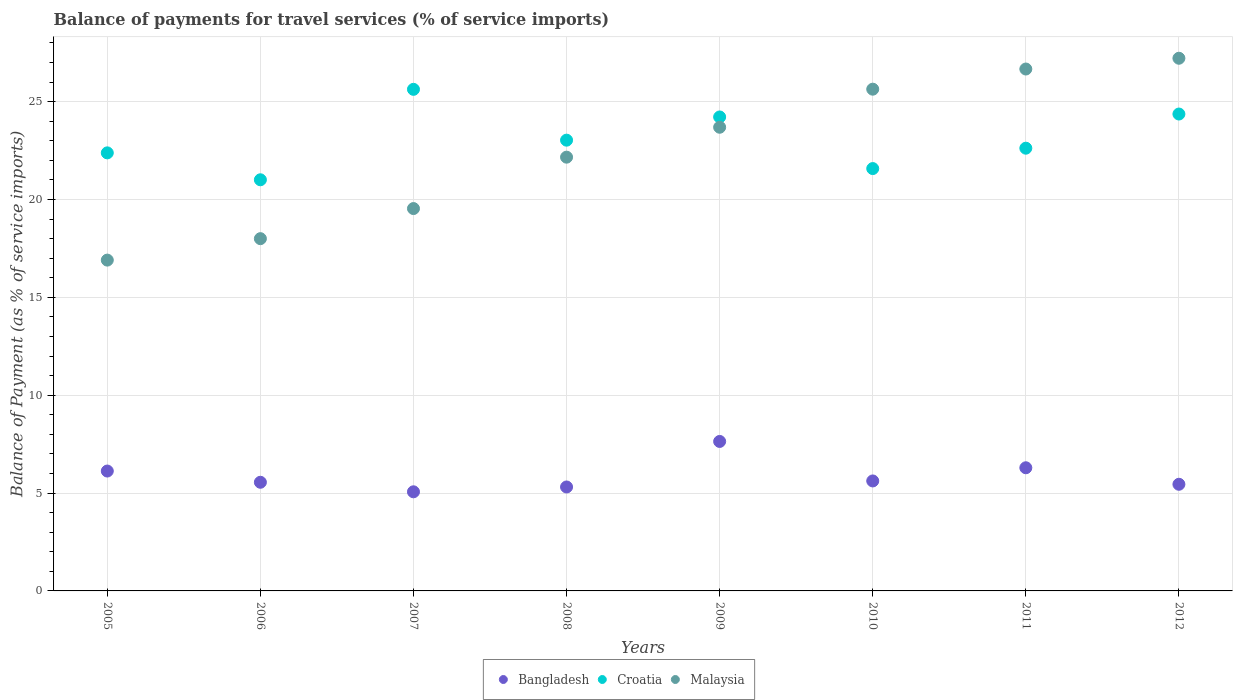What is the balance of payments for travel services in Bangladesh in 2012?
Give a very brief answer. 5.45. Across all years, what is the maximum balance of payments for travel services in Croatia?
Offer a very short reply. 25.63. Across all years, what is the minimum balance of payments for travel services in Croatia?
Ensure brevity in your answer.  21.01. In which year was the balance of payments for travel services in Croatia minimum?
Give a very brief answer. 2006. What is the total balance of payments for travel services in Croatia in the graph?
Make the answer very short. 184.84. What is the difference between the balance of payments for travel services in Croatia in 2006 and that in 2012?
Provide a short and direct response. -3.36. What is the difference between the balance of payments for travel services in Croatia in 2006 and the balance of payments for travel services in Bangladesh in 2012?
Keep it short and to the point. 15.56. What is the average balance of payments for travel services in Malaysia per year?
Provide a succinct answer. 22.48. In the year 2009, what is the difference between the balance of payments for travel services in Bangladesh and balance of payments for travel services in Malaysia?
Offer a terse response. -16.05. What is the ratio of the balance of payments for travel services in Malaysia in 2005 to that in 2012?
Offer a terse response. 0.62. Is the balance of payments for travel services in Croatia in 2005 less than that in 2007?
Keep it short and to the point. Yes. Is the difference between the balance of payments for travel services in Bangladesh in 2007 and 2012 greater than the difference between the balance of payments for travel services in Malaysia in 2007 and 2012?
Your response must be concise. Yes. What is the difference between the highest and the second highest balance of payments for travel services in Croatia?
Your response must be concise. 1.26. What is the difference between the highest and the lowest balance of payments for travel services in Croatia?
Keep it short and to the point. 4.62. Is it the case that in every year, the sum of the balance of payments for travel services in Croatia and balance of payments for travel services in Malaysia  is greater than the balance of payments for travel services in Bangladesh?
Provide a succinct answer. Yes. Does the balance of payments for travel services in Malaysia monotonically increase over the years?
Offer a terse response. Yes. Is the balance of payments for travel services in Croatia strictly less than the balance of payments for travel services in Malaysia over the years?
Offer a very short reply. No. Are the values on the major ticks of Y-axis written in scientific E-notation?
Offer a very short reply. No. Does the graph contain any zero values?
Your answer should be compact. No. Where does the legend appear in the graph?
Provide a short and direct response. Bottom center. How many legend labels are there?
Offer a very short reply. 3. What is the title of the graph?
Ensure brevity in your answer.  Balance of payments for travel services (% of service imports). What is the label or title of the X-axis?
Provide a succinct answer. Years. What is the label or title of the Y-axis?
Your answer should be compact. Balance of Payment (as % of service imports). What is the Balance of Payment (as % of service imports) of Bangladesh in 2005?
Your response must be concise. 6.13. What is the Balance of Payment (as % of service imports) in Croatia in 2005?
Offer a terse response. 22.38. What is the Balance of Payment (as % of service imports) of Malaysia in 2005?
Your response must be concise. 16.9. What is the Balance of Payment (as % of service imports) of Bangladesh in 2006?
Your response must be concise. 5.55. What is the Balance of Payment (as % of service imports) in Croatia in 2006?
Ensure brevity in your answer.  21.01. What is the Balance of Payment (as % of service imports) of Malaysia in 2006?
Your response must be concise. 18. What is the Balance of Payment (as % of service imports) in Bangladesh in 2007?
Offer a very short reply. 5.06. What is the Balance of Payment (as % of service imports) in Croatia in 2007?
Provide a short and direct response. 25.63. What is the Balance of Payment (as % of service imports) in Malaysia in 2007?
Give a very brief answer. 19.54. What is the Balance of Payment (as % of service imports) in Bangladesh in 2008?
Keep it short and to the point. 5.31. What is the Balance of Payment (as % of service imports) in Croatia in 2008?
Offer a terse response. 23.03. What is the Balance of Payment (as % of service imports) of Malaysia in 2008?
Ensure brevity in your answer.  22.16. What is the Balance of Payment (as % of service imports) of Bangladesh in 2009?
Give a very brief answer. 7.64. What is the Balance of Payment (as % of service imports) in Croatia in 2009?
Provide a short and direct response. 24.22. What is the Balance of Payment (as % of service imports) of Malaysia in 2009?
Provide a short and direct response. 23.69. What is the Balance of Payment (as % of service imports) in Bangladesh in 2010?
Offer a terse response. 5.62. What is the Balance of Payment (as % of service imports) in Croatia in 2010?
Make the answer very short. 21.58. What is the Balance of Payment (as % of service imports) of Malaysia in 2010?
Your answer should be very brief. 25.64. What is the Balance of Payment (as % of service imports) of Bangladesh in 2011?
Your answer should be compact. 6.29. What is the Balance of Payment (as % of service imports) in Croatia in 2011?
Provide a short and direct response. 22.62. What is the Balance of Payment (as % of service imports) in Malaysia in 2011?
Offer a terse response. 26.67. What is the Balance of Payment (as % of service imports) in Bangladesh in 2012?
Offer a very short reply. 5.45. What is the Balance of Payment (as % of service imports) of Croatia in 2012?
Ensure brevity in your answer.  24.37. What is the Balance of Payment (as % of service imports) of Malaysia in 2012?
Offer a terse response. 27.22. Across all years, what is the maximum Balance of Payment (as % of service imports) of Bangladesh?
Give a very brief answer. 7.64. Across all years, what is the maximum Balance of Payment (as % of service imports) in Croatia?
Ensure brevity in your answer.  25.63. Across all years, what is the maximum Balance of Payment (as % of service imports) in Malaysia?
Provide a succinct answer. 27.22. Across all years, what is the minimum Balance of Payment (as % of service imports) in Bangladesh?
Your response must be concise. 5.06. Across all years, what is the minimum Balance of Payment (as % of service imports) of Croatia?
Offer a very short reply. 21.01. Across all years, what is the minimum Balance of Payment (as % of service imports) in Malaysia?
Your answer should be compact. 16.9. What is the total Balance of Payment (as % of service imports) in Bangladesh in the graph?
Give a very brief answer. 47.05. What is the total Balance of Payment (as % of service imports) of Croatia in the graph?
Give a very brief answer. 184.84. What is the total Balance of Payment (as % of service imports) of Malaysia in the graph?
Offer a very short reply. 179.81. What is the difference between the Balance of Payment (as % of service imports) of Bangladesh in 2005 and that in 2006?
Give a very brief answer. 0.57. What is the difference between the Balance of Payment (as % of service imports) in Croatia in 2005 and that in 2006?
Provide a short and direct response. 1.38. What is the difference between the Balance of Payment (as % of service imports) of Malaysia in 2005 and that in 2006?
Ensure brevity in your answer.  -1.1. What is the difference between the Balance of Payment (as % of service imports) of Bangladesh in 2005 and that in 2007?
Your answer should be very brief. 1.06. What is the difference between the Balance of Payment (as % of service imports) in Croatia in 2005 and that in 2007?
Your answer should be very brief. -3.25. What is the difference between the Balance of Payment (as % of service imports) of Malaysia in 2005 and that in 2007?
Provide a short and direct response. -2.63. What is the difference between the Balance of Payment (as % of service imports) in Bangladesh in 2005 and that in 2008?
Your answer should be compact. 0.81. What is the difference between the Balance of Payment (as % of service imports) in Croatia in 2005 and that in 2008?
Provide a short and direct response. -0.65. What is the difference between the Balance of Payment (as % of service imports) of Malaysia in 2005 and that in 2008?
Your answer should be very brief. -5.26. What is the difference between the Balance of Payment (as % of service imports) of Bangladesh in 2005 and that in 2009?
Give a very brief answer. -1.51. What is the difference between the Balance of Payment (as % of service imports) of Croatia in 2005 and that in 2009?
Offer a very short reply. -1.83. What is the difference between the Balance of Payment (as % of service imports) in Malaysia in 2005 and that in 2009?
Make the answer very short. -6.79. What is the difference between the Balance of Payment (as % of service imports) of Bangladesh in 2005 and that in 2010?
Make the answer very short. 0.51. What is the difference between the Balance of Payment (as % of service imports) of Croatia in 2005 and that in 2010?
Your response must be concise. 0.8. What is the difference between the Balance of Payment (as % of service imports) in Malaysia in 2005 and that in 2010?
Your answer should be very brief. -8.73. What is the difference between the Balance of Payment (as % of service imports) of Bangladesh in 2005 and that in 2011?
Ensure brevity in your answer.  -0.17. What is the difference between the Balance of Payment (as % of service imports) in Croatia in 2005 and that in 2011?
Your response must be concise. -0.24. What is the difference between the Balance of Payment (as % of service imports) in Malaysia in 2005 and that in 2011?
Provide a succinct answer. -9.76. What is the difference between the Balance of Payment (as % of service imports) of Bangladesh in 2005 and that in 2012?
Keep it short and to the point. 0.68. What is the difference between the Balance of Payment (as % of service imports) of Croatia in 2005 and that in 2012?
Your response must be concise. -1.98. What is the difference between the Balance of Payment (as % of service imports) in Malaysia in 2005 and that in 2012?
Offer a terse response. -10.31. What is the difference between the Balance of Payment (as % of service imports) in Bangladesh in 2006 and that in 2007?
Your answer should be compact. 0.49. What is the difference between the Balance of Payment (as % of service imports) in Croatia in 2006 and that in 2007?
Give a very brief answer. -4.62. What is the difference between the Balance of Payment (as % of service imports) of Malaysia in 2006 and that in 2007?
Ensure brevity in your answer.  -1.54. What is the difference between the Balance of Payment (as % of service imports) of Bangladesh in 2006 and that in 2008?
Your answer should be very brief. 0.24. What is the difference between the Balance of Payment (as % of service imports) of Croatia in 2006 and that in 2008?
Your answer should be very brief. -2.02. What is the difference between the Balance of Payment (as % of service imports) in Malaysia in 2006 and that in 2008?
Make the answer very short. -4.16. What is the difference between the Balance of Payment (as % of service imports) of Bangladesh in 2006 and that in 2009?
Provide a succinct answer. -2.09. What is the difference between the Balance of Payment (as % of service imports) of Croatia in 2006 and that in 2009?
Keep it short and to the point. -3.21. What is the difference between the Balance of Payment (as % of service imports) in Malaysia in 2006 and that in 2009?
Provide a succinct answer. -5.69. What is the difference between the Balance of Payment (as % of service imports) of Bangladesh in 2006 and that in 2010?
Provide a succinct answer. -0.07. What is the difference between the Balance of Payment (as % of service imports) of Croatia in 2006 and that in 2010?
Provide a short and direct response. -0.57. What is the difference between the Balance of Payment (as % of service imports) in Malaysia in 2006 and that in 2010?
Offer a terse response. -7.64. What is the difference between the Balance of Payment (as % of service imports) in Bangladesh in 2006 and that in 2011?
Keep it short and to the point. -0.74. What is the difference between the Balance of Payment (as % of service imports) in Croatia in 2006 and that in 2011?
Provide a short and direct response. -1.61. What is the difference between the Balance of Payment (as % of service imports) of Malaysia in 2006 and that in 2011?
Your response must be concise. -8.67. What is the difference between the Balance of Payment (as % of service imports) of Bangladesh in 2006 and that in 2012?
Offer a very short reply. 0.1. What is the difference between the Balance of Payment (as % of service imports) in Croatia in 2006 and that in 2012?
Your answer should be very brief. -3.36. What is the difference between the Balance of Payment (as % of service imports) of Malaysia in 2006 and that in 2012?
Offer a terse response. -9.22. What is the difference between the Balance of Payment (as % of service imports) of Bangladesh in 2007 and that in 2008?
Make the answer very short. -0.25. What is the difference between the Balance of Payment (as % of service imports) in Croatia in 2007 and that in 2008?
Your response must be concise. 2.6. What is the difference between the Balance of Payment (as % of service imports) in Malaysia in 2007 and that in 2008?
Provide a short and direct response. -2.63. What is the difference between the Balance of Payment (as % of service imports) of Bangladesh in 2007 and that in 2009?
Keep it short and to the point. -2.57. What is the difference between the Balance of Payment (as % of service imports) in Croatia in 2007 and that in 2009?
Give a very brief answer. 1.41. What is the difference between the Balance of Payment (as % of service imports) in Malaysia in 2007 and that in 2009?
Your response must be concise. -4.15. What is the difference between the Balance of Payment (as % of service imports) in Bangladesh in 2007 and that in 2010?
Offer a very short reply. -0.55. What is the difference between the Balance of Payment (as % of service imports) in Croatia in 2007 and that in 2010?
Offer a terse response. 4.05. What is the difference between the Balance of Payment (as % of service imports) in Malaysia in 2007 and that in 2010?
Make the answer very short. -6.1. What is the difference between the Balance of Payment (as % of service imports) of Bangladesh in 2007 and that in 2011?
Ensure brevity in your answer.  -1.23. What is the difference between the Balance of Payment (as % of service imports) in Croatia in 2007 and that in 2011?
Provide a succinct answer. 3.01. What is the difference between the Balance of Payment (as % of service imports) of Malaysia in 2007 and that in 2011?
Give a very brief answer. -7.13. What is the difference between the Balance of Payment (as % of service imports) in Bangladesh in 2007 and that in 2012?
Your answer should be very brief. -0.38. What is the difference between the Balance of Payment (as % of service imports) of Croatia in 2007 and that in 2012?
Make the answer very short. 1.26. What is the difference between the Balance of Payment (as % of service imports) in Malaysia in 2007 and that in 2012?
Provide a succinct answer. -7.68. What is the difference between the Balance of Payment (as % of service imports) of Bangladesh in 2008 and that in 2009?
Make the answer very short. -2.33. What is the difference between the Balance of Payment (as % of service imports) of Croatia in 2008 and that in 2009?
Ensure brevity in your answer.  -1.19. What is the difference between the Balance of Payment (as % of service imports) in Malaysia in 2008 and that in 2009?
Your response must be concise. -1.53. What is the difference between the Balance of Payment (as % of service imports) in Bangladesh in 2008 and that in 2010?
Your answer should be very brief. -0.31. What is the difference between the Balance of Payment (as % of service imports) of Croatia in 2008 and that in 2010?
Your answer should be compact. 1.45. What is the difference between the Balance of Payment (as % of service imports) of Malaysia in 2008 and that in 2010?
Ensure brevity in your answer.  -3.47. What is the difference between the Balance of Payment (as % of service imports) of Bangladesh in 2008 and that in 2011?
Your response must be concise. -0.98. What is the difference between the Balance of Payment (as % of service imports) in Croatia in 2008 and that in 2011?
Make the answer very short. 0.41. What is the difference between the Balance of Payment (as % of service imports) of Malaysia in 2008 and that in 2011?
Ensure brevity in your answer.  -4.5. What is the difference between the Balance of Payment (as % of service imports) of Bangladesh in 2008 and that in 2012?
Provide a succinct answer. -0.14. What is the difference between the Balance of Payment (as % of service imports) in Croatia in 2008 and that in 2012?
Keep it short and to the point. -1.34. What is the difference between the Balance of Payment (as % of service imports) of Malaysia in 2008 and that in 2012?
Keep it short and to the point. -5.05. What is the difference between the Balance of Payment (as % of service imports) of Bangladesh in 2009 and that in 2010?
Provide a succinct answer. 2.02. What is the difference between the Balance of Payment (as % of service imports) in Croatia in 2009 and that in 2010?
Offer a very short reply. 2.64. What is the difference between the Balance of Payment (as % of service imports) of Malaysia in 2009 and that in 2010?
Offer a terse response. -1.95. What is the difference between the Balance of Payment (as % of service imports) in Bangladesh in 2009 and that in 2011?
Provide a short and direct response. 1.34. What is the difference between the Balance of Payment (as % of service imports) of Croatia in 2009 and that in 2011?
Keep it short and to the point. 1.6. What is the difference between the Balance of Payment (as % of service imports) of Malaysia in 2009 and that in 2011?
Provide a short and direct response. -2.98. What is the difference between the Balance of Payment (as % of service imports) of Bangladesh in 2009 and that in 2012?
Ensure brevity in your answer.  2.19. What is the difference between the Balance of Payment (as % of service imports) in Croatia in 2009 and that in 2012?
Your answer should be very brief. -0.15. What is the difference between the Balance of Payment (as % of service imports) in Malaysia in 2009 and that in 2012?
Give a very brief answer. -3.53. What is the difference between the Balance of Payment (as % of service imports) in Bangladesh in 2010 and that in 2011?
Your answer should be very brief. -0.67. What is the difference between the Balance of Payment (as % of service imports) in Croatia in 2010 and that in 2011?
Your response must be concise. -1.04. What is the difference between the Balance of Payment (as % of service imports) in Malaysia in 2010 and that in 2011?
Your answer should be very brief. -1.03. What is the difference between the Balance of Payment (as % of service imports) in Bangladesh in 2010 and that in 2012?
Give a very brief answer. 0.17. What is the difference between the Balance of Payment (as % of service imports) of Croatia in 2010 and that in 2012?
Offer a very short reply. -2.79. What is the difference between the Balance of Payment (as % of service imports) in Malaysia in 2010 and that in 2012?
Your answer should be very brief. -1.58. What is the difference between the Balance of Payment (as % of service imports) in Bangladesh in 2011 and that in 2012?
Your answer should be compact. 0.84. What is the difference between the Balance of Payment (as % of service imports) in Croatia in 2011 and that in 2012?
Provide a succinct answer. -1.75. What is the difference between the Balance of Payment (as % of service imports) of Malaysia in 2011 and that in 2012?
Offer a very short reply. -0.55. What is the difference between the Balance of Payment (as % of service imports) in Bangladesh in 2005 and the Balance of Payment (as % of service imports) in Croatia in 2006?
Give a very brief answer. -14.88. What is the difference between the Balance of Payment (as % of service imports) of Bangladesh in 2005 and the Balance of Payment (as % of service imports) of Malaysia in 2006?
Your answer should be very brief. -11.87. What is the difference between the Balance of Payment (as % of service imports) in Croatia in 2005 and the Balance of Payment (as % of service imports) in Malaysia in 2006?
Ensure brevity in your answer.  4.38. What is the difference between the Balance of Payment (as % of service imports) in Bangladesh in 2005 and the Balance of Payment (as % of service imports) in Croatia in 2007?
Provide a short and direct response. -19.5. What is the difference between the Balance of Payment (as % of service imports) in Bangladesh in 2005 and the Balance of Payment (as % of service imports) in Malaysia in 2007?
Provide a short and direct response. -13.41. What is the difference between the Balance of Payment (as % of service imports) in Croatia in 2005 and the Balance of Payment (as % of service imports) in Malaysia in 2007?
Ensure brevity in your answer.  2.85. What is the difference between the Balance of Payment (as % of service imports) in Bangladesh in 2005 and the Balance of Payment (as % of service imports) in Croatia in 2008?
Ensure brevity in your answer.  -16.91. What is the difference between the Balance of Payment (as % of service imports) of Bangladesh in 2005 and the Balance of Payment (as % of service imports) of Malaysia in 2008?
Ensure brevity in your answer.  -16.04. What is the difference between the Balance of Payment (as % of service imports) of Croatia in 2005 and the Balance of Payment (as % of service imports) of Malaysia in 2008?
Keep it short and to the point. 0.22. What is the difference between the Balance of Payment (as % of service imports) in Bangladesh in 2005 and the Balance of Payment (as % of service imports) in Croatia in 2009?
Provide a short and direct response. -18.09. What is the difference between the Balance of Payment (as % of service imports) in Bangladesh in 2005 and the Balance of Payment (as % of service imports) in Malaysia in 2009?
Your response must be concise. -17.57. What is the difference between the Balance of Payment (as % of service imports) in Croatia in 2005 and the Balance of Payment (as % of service imports) in Malaysia in 2009?
Keep it short and to the point. -1.31. What is the difference between the Balance of Payment (as % of service imports) of Bangladesh in 2005 and the Balance of Payment (as % of service imports) of Croatia in 2010?
Keep it short and to the point. -15.46. What is the difference between the Balance of Payment (as % of service imports) in Bangladesh in 2005 and the Balance of Payment (as % of service imports) in Malaysia in 2010?
Provide a succinct answer. -19.51. What is the difference between the Balance of Payment (as % of service imports) in Croatia in 2005 and the Balance of Payment (as % of service imports) in Malaysia in 2010?
Offer a terse response. -3.25. What is the difference between the Balance of Payment (as % of service imports) of Bangladesh in 2005 and the Balance of Payment (as % of service imports) of Croatia in 2011?
Provide a short and direct response. -16.5. What is the difference between the Balance of Payment (as % of service imports) in Bangladesh in 2005 and the Balance of Payment (as % of service imports) in Malaysia in 2011?
Your answer should be very brief. -20.54. What is the difference between the Balance of Payment (as % of service imports) in Croatia in 2005 and the Balance of Payment (as % of service imports) in Malaysia in 2011?
Ensure brevity in your answer.  -4.28. What is the difference between the Balance of Payment (as % of service imports) of Bangladesh in 2005 and the Balance of Payment (as % of service imports) of Croatia in 2012?
Offer a terse response. -18.24. What is the difference between the Balance of Payment (as % of service imports) of Bangladesh in 2005 and the Balance of Payment (as % of service imports) of Malaysia in 2012?
Keep it short and to the point. -21.09. What is the difference between the Balance of Payment (as % of service imports) in Croatia in 2005 and the Balance of Payment (as % of service imports) in Malaysia in 2012?
Your answer should be very brief. -4.83. What is the difference between the Balance of Payment (as % of service imports) of Bangladesh in 2006 and the Balance of Payment (as % of service imports) of Croatia in 2007?
Make the answer very short. -20.08. What is the difference between the Balance of Payment (as % of service imports) of Bangladesh in 2006 and the Balance of Payment (as % of service imports) of Malaysia in 2007?
Your answer should be very brief. -13.99. What is the difference between the Balance of Payment (as % of service imports) in Croatia in 2006 and the Balance of Payment (as % of service imports) in Malaysia in 2007?
Offer a terse response. 1.47. What is the difference between the Balance of Payment (as % of service imports) in Bangladesh in 2006 and the Balance of Payment (as % of service imports) in Croatia in 2008?
Your response must be concise. -17.48. What is the difference between the Balance of Payment (as % of service imports) of Bangladesh in 2006 and the Balance of Payment (as % of service imports) of Malaysia in 2008?
Give a very brief answer. -16.61. What is the difference between the Balance of Payment (as % of service imports) in Croatia in 2006 and the Balance of Payment (as % of service imports) in Malaysia in 2008?
Give a very brief answer. -1.16. What is the difference between the Balance of Payment (as % of service imports) of Bangladesh in 2006 and the Balance of Payment (as % of service imports) of Croatia in 2009?
Provide a succinct answer. -18.67. What is the difference between the Balance of Payment (as % of service imports) in Bangladesh in 2006 and the Balance of Payment (as % of service imports) in Malaysia in 2009?
Provide a short and direct response. -18.14. What is the difference between the Balance of Payment (as % of service imports) in Croatia in 2006 and the Balance of Payment (as % of service imports) in Malaysia in 2009?
Offer a terse response. -2.68. What is the difference between the Balance of Payment (as % of service imports) in Bangladesh in 2006 and the Balance of Payment (as % of service imports) in Croatia in 2010?
Offer a very short reply. -16.03. What is the difference between the Balance of Payment (as % of service imports) of Bangladesh in 2006 and the Balance of Payment (as % of service imports) of Malaysia in 2010?
Give a very brief answer. -20.08. What is the difference between the Balance of Payment (as % of service imports) of Croatia in 2006 and the Balance of Payment (as % of service imports) of Malaysia in 2010?
Your answer should be very brief. -4.63. What is the difference between the Balance of Payment (as % of service imports) of Bangladesh in 2006 and the Balance of Payment (as % of service imports) of Croatia in 2011?
Offer a very short reply. -17.07. What is the difference between the Balance of Payment (as % of service imports) in Bangladesh in 2006 and the Balance of Payment (as % of service imports) in Malaysia in 2011?
Your answer should be very brief. -21.12. What is the difference between the Balance of Payment (as % of service imports) in Croatia in 2006 and the Balance of Payment (as % of service imports) in Malaysia in 2011?
Provide a succinct answer. -5.66. What is the difference between the Balance of Payment (as % of service imports) of Bangladesh in 2006 and the Balance of Payment (as % of service imports) of Croatia in 2012?
Provide a succinct answer. -18.82. What is the difference between the Balance of Payment (as % of service imports) in Bangladesh in 2006 and the Balance of Payment (as % of service imports) in Malaysia in 2012?
Your answer should be very brief. -21.67. What is the difference between the Balance of Payment (as % of service imports) of Croatia in 2006 and the Balance of Payment (as % of service imports) of Malaysia in 2012?
Your answer should be compact. -6.21. What is the difference between the Balance of Payment (as % of service imports) of Bangladesh in 2007 and the Balance of Payment (as % of service imports) of Croatia in 2008?
Make the answer very short. -17.97. What is the difference between the Balance of Payment (as % of service imports) of Bangladesh in 2007 and the Balance of Payment (as % of service imports) of Malaysia in 2008?
Offer a terse response. -17.1. What is the difference between the Balance of Payment (as % of service imports) of Croatia in 2007 and the Balance of Payment (as % of service imports) of Malaysia in 2008?
Your answer should be compact. 3.47. What is the difference between the Balance of Payment (as % of service imports) in Bangladesh in 2007 and the Balance of Payment (as % of service imports) in Croatia in 2009?
Make the answer very short. -19.15. What is the difference between the Balance of Payment (as % of service imports) of Bangladesh in 2007 and the Balance of Payment (as % of service imports) of Malaysia in 2009?
Provide a short and direct response. -18.63. What is the difference between the Balance of Payment (as % of service imports) in Croatia in 2007 and the Balance of Payment (as % of service imports) in Malaysia in 2009?
Your answer should be very brief. 1.94. What is the difference between the Balance of Payment (as % of service imports) in Bangladesh in 2007 and the Balance of Payment (as % of service imports) in Croatia in 2010?
Offer a very short reply. -16.52. What is the difference between the Balance of Payment (as % of service imports) of Bangladesh in 2007 and the Balance of Payment (as % of service imports) of Malaysia in 2010?
Keep it short and to the point. -20.57. What is the difference between the Balance of Payment (as % of service imports) of Croatia in 2007 and the Balance of Payment (as % of service imports) of Malaysia in 2010?
Offer a terse response. -0.01. What is the difference between the Balance of Payment (as % of service imports) of Bangladesh in 2007 and the Balance of Payment (as % of service imports) of Croatia in 2011?
Provide a succinct answer. -17.56. What is the difference between the Balance of Payment (as % of service imports) of Bangladesh in 2007 and the Balance of Payment (as % of service imports) of Malaysia in 2011?
Give a very brief answer. -21.6. What is the difference between the Balance of Payment (as % of service imports) in Croatia in 2007 and the Balance of Payment (as % of service imports) in Malaysia in 2011?
Offer a very short reply. -1.04. What is the difference between the Balance of Payment (as % of service imports) in Bangladesh in 2007 and the Balance of Payment (as % of service imports) in Croatia in 2012?
Keep it short and to the point. -19.3. What is the difference between the Balance of Payment (as % of service imports) of Bangladesh in 2007 and the Balance of Payment (as % of service imports) of Malaysia in 2012?
Ensure brevity in your answer.  -22.15. What is the difference between the Balance of Payment (as % of service imports) of Croatia in 2007 and the Balance of Payment (as % of service imports) of Malaysia in 2012?
Keep it short and to the point. -1.59. What is the difference between the Balance of Payment (as % of service imports) in Bangladesh in 2008 and the Balance of Payment (as % of service imports) in Croatia in 2009?
Keep it short and to the point. -18.91. What is the difference between the Balance of Payment (as % of service imports) of Bangladesh in 2008 and the Balance of Payment (as % of service imports) of Malaysia in 2009?
Offer a very short reply. -18.38. What is the difference between the Balance of Payment (as % of service imports) of Croatia in 2008 and the Balance of Payment (as % of service imports) of Malaysia in 2009?
Offer a very short reply. -0.66. What is the difference between the Balance of Payment (as % of service imports) of Bangladesh in 2008 and the Balance of Payment (as % of service imports) of Croatia in 2010?
Provide a short and direct response. -16.27. What is the difference between the Balance of Payment (as % of service imports) of Bangladesh in 2008 and the Balance of Payment (as % of service imports) of Malaysia in 2010?
Offer a very short reply. -20.33. What is the difference between the Balance of Payment (as % of service imports) in Croatia in 2008 and the Balance of Payment (as % of service imports) in Malaysia in 2010?
Provide a short and direct response. -2.6. What is the difference between the Balance of Payment (as % of service imports) of Bangladesh in 2008 and the Balance of Payment (as % of service imports) of Croatia in 2011?
Provide a short and direct response. -17.31. What is the difference between the Balance of Payment (as % of service imports) in Bangladesh in 2008 and the Balance of Payment (as % of service imports) in Malaysia in 2011?
Provide a short and direct response. -21.36. What is the difference between the Balance of Payment (as % of service imports) of Croatia in 2008 and the Balance of Payment (as % of service imports) of Malaysia in 2011?
Offer a terse response. -3.64. What is the difference between the Balance of Payment (as % of service imports) in Bangladesh in 2008 and the Balance of Payment (as % of service imports) in Croatia in 2012?
Offer a terse response. -19.06. What is the difference between the Balance of Payment (as % of service imports) of Bangladesh in 2008 and the Balance of Payment (as % of service imports) of Malaysia in 2012?
Offer a very short reply. -21.91. What is the difference between the Balance of Payment (as % of service imports) in Croatia in 2008 and the Balance of Payment (as % of service imports) in Malaysia in 2012?
Ensure brevity in your answer.  -4.19. What is the difference between the Balance of Payment (as % of service imports) in Bangladesh in 2009 and the Balance of Payment (as % of service imports) in Croatia in 2010?
Ensure brevity in your answer.  -13.94. What is the difference between the Balance of Payment (as % of service imports) of Bangladesh in 2009 and the Balance of Payment (as % of service imports) of Malaysia in 2010?
Ensure brevity in your answer.  -18. What is the difference between the Balance of Payment (as % of service imports) in Croatia in 2009 and the Balance of Payment (as % of service imports) in Malaysia in 2010?
Provide a short and direct response. -1.42. What is the difference between the Balance of Payment (as % of service imports) of Bangladesh in 2009 and the Balance of Payment (as % of service imports) of Croatia in 2011?
Give a very brief answer. -14.98. What is the difference between the Balance of Payment (as % of service imports) of Bangladesh in 2009 and the Balance of Payment (as % of service imports) of Malaysia in 2011?
Your answer should be compact. -19.03. What is the difference between the Balance of Payment (as % of service imports) of Croatia in 2009 and the Balance of Payment (as % of service imports) of Malaysia in 2011?
Ensure brevity in your answer.  -2.45. What is the difference between the Balance of Payment (as % of service imports) in Bangladesh in 2009 and the Balance of Payment (as % of service imports) in Croatia in 2012?
Give a very brief answer. -16.73. What is the difference between the Balance of Payment (as % of service imports) in Bangladesh in 2009 and the Balance of Payment (as % of service imports) in Malaysia in 2012?
Ensure brevity in your answer.  -19.58. What is the difference between the Balance of Payment (as % of service imports) in Croatia in 2009 and the Balance of Payment (as % of service imports) in Malaysia in 2012?
Your response must be concise. -3. What is the difference between the Balance of Payment (as % of service imports) in Bangladesh in 2010 and the Balance of Payment (as % of service imports) in Croatia in 2011?
Keep it short and to the point. -17. What is the difference between the Balance of Payment (as % of service imports) of Bangladesh in 2010 and the Balance of Payment (as % of service imports) of Malaysia in 2011?
Provide a succinct answer. -21.05. What is the difference between the Balance of Payment (as % of service imports) of Croatia in 2010 and the Balance of Payment (as % of service imports) of Malaysia in 2011?
Provide a succinct answer. -5.09. What is the difference between the Balance of Payment (as % of service imports) of Bangladesh in 2010 and the Balance of Payment (as % of service imports) of Croatia in 2012?
Your answer should be compact. -18.75. What is the difference between the Balance of Payment (as % of service imports) of Bangladesh in 2010 and the Balance of Payment (as % of service imports) of Malaysia in 2012?
Offer a terse response. -21.6. What is the difference between the Balance of Payment (as % of service imports) in Croatia in 2010 and the Balance of Payment (as % of service imports) in Malaysia in 2012?
Provide a short and direct response. -5.64. What is the difference between the Balance of Payment (as % of service imports) of Bangladesh in 2011 and the Balance of Payment (as % of service imports) of Croatia in 2012?
Your answer should be very brief. -18.07. What is the difference between the Balance of Payment (as % of service imports) of Bangladesh in 2011 and the Balance of Payment (as % of service imports) of Malaysia in 2012?
Your response must be concise. -20.92. What is the difference between the Balance of Payment (as % of service imports) in Croatia in 2011 and the Balance of Payment (as % of service imports) in Malaysia in 2012?
Your response must be concise. -4.6. What is the average Balance of Payment (as % of service imports) of Bangladesh per year?
Offer a terse response. 5.88. What is the average Balance of Payment (as % of service imports) in Croatia per year?
Offer a very short reply. 23.1. What is the average Balance of Payment (as % of service imports) of Malaysia per year?
Offer a terse response. 22.48. In the year 2005, what is the difference between the Balance of Payment (as % of service imports) of Bangladesh and Balance of Payment (as % of service imports) of Croatia?
Keep it short and to the point. -16.26. In the year 2005, what is the difference between the Balance of Payment (as % of service imports) in Bangladesh and Balance of Payment (as % of service imports) in Malaysia?
Provide a succinct answer. -10.78. In the year 2005, what is the difference between the Balance of Payment (as % of service imports) of Croatia and Balance of Payment (as % of service imports) of Malaysia?
Give a very brief answer. 5.48. In the year 2006, what is the difference between the Balance of Payment (as % of service imports) of Bangladesh and Balance of Payment (as % of service imports) of Croatia?
Provide a succinct answer. -15.46. In the year 2006, what is the difference between the Balance of Payment (as % of service imports) of Bangladesh and Balance of Payment (as % of service imports) of Malaysia?
Make the answer very short. -12.45. In the year 2006, what is the difference between the Balance of Payment (as % of service imports) of Croatia and Balance of Payment (as % of service imports) of Malaysia?
Provide a short and direct response. 3.01. In the year 2007, what is the difference between the Balance of Payment (as % of service imports) in Bangladesh and Balance of Payment (as % of service imports) in Croatia?
Keep it short and to the point. -20.56. In the year 2007, what is the difference between the Balance of Payment (as % of service imports) of Bangladesh and Balance of Payment (as % of service imports) of Malaysia?
Give a very brief answer. -14.47. In the year 2007, what is the difference between the Balance of Payment (as % of service imports) of Croatia and Balance of Payment (as % of service imports) of Malaysia?
Your answer should be compact. 6.09. In the year 2008, what is the difference between the Balance of Payment (as % of service imports) in Bangladesh and Balance of Payment (as % of service imports) in Croatia?
Offer a terse response. -17.72. In the year 2008, what is the difference between the Balance of Payment (as % of service imports) of Bangladesh and Balance of Payment (as % of service imports) of Malaysia?
Your response must be concise. -16.85. In the year 2008, what is the difference between the Balance of Payment (as % of service imports) of Croatia and Balance of Payment (as % of service imports) of Malaysia?
Your answer should be very brief. 0.87. In the year 2009, what is the difference between the Balance of Payment (as % of service imports) of Bangladesh and Balance of Payment (as % of service imports) of Croatia?
Your answer should be very brief. -16.58. In the year 2009, what is the difference between the Balance of Payment (as % of service imports) in Bangladesh and Balance of Payment (as % of service imports) in Malaysia?
Keep it short and to the point. -16.05. In the year 2009, what is the difference between the Balance of Payment (as % of service imports) of Croatia and Balance of Payment (as % of service imports) of Malaysia?
Your answer should be very brief. 0.53. In the year 2010, what is the difference between the Balance of Payment (as % of service imports) of Bangladesh and Balance of Payment (as % of service imports) of Croatia?
Provide a short and direct response. -15.96. In the year 2010, what is the difference between the Balance of Payment (as % of service imports) of Bangladesh and Balance of Payment (as % of service imports) of Malaysia?
Give a very brief answer. -20.02. In the year 2010, what is the difference between the Balance of Payment (as % of service imports) of Croatia and Balance of Payment (as % of service imports) of Malaysia?
Your answer should be compact. -4.06. In the year 2011, what is the difference between the Balance of Payment (as % of service imports) of Bangladesh and Balance of Payment (as % of service imports) of Croatia?
Give a very brief answer. -16.33. In the year 2011, what is the difference between the Balance of Payment (as % of service imports) of Bangladesh and Balance of Payment (as % of service imports) of Malaysia?
Keep it short and to the point. -20.37. In the year 2011, what is the difference between the Balance of Payment (as % of service imports) in Croatia and Balance of Payment (as % of service imports) in Malaysia?
Make the answer very short. -4.05. In the year 2012, what is the difference between the Balance of Payment (as % of service imports) of Bangladesh and Balance of Payment (as % of service imports) of Croatia?
Your answer should be compact. -18.92. In the year 2012, what is the difference between the Balance of Payment (as % of service imports) in Bangladesh and Balance of Payment (as % of service imports) in Malaysia?
Give a very brief answer. -21.77. In the year 2012, what is the difference between the Balance of Payment (as % of service imports) in Croatia and Balance of Payment (as % of service imports) in Malaysia?
Your response must be concise. -2.85. What is the ratio of the Balance of Payment (as % of service imports) of Bangladesh in 2005 to that in 2006?
Provide a short and direct response. 1.1. What is the ratio of the Balance of Payment (as % of service imports) of Croatia in 2005 to that in 2006?
Provide a short and direct response. 1.07. What is the ratio of the Balance of Payment (as % of service imports) in Malaysia in 2005 to that in 2006?
Keep it short and to the point. 0.94. What is the ratio of the Balance of Payment (as % of service imports) in Bangladesh in 2005 to that in 2007?
Your answer should be compact. 1.21. What is the ratio of the Balance of Payment (as % of service imports) in Croatia in 2005 to that in 2007?
Ensure brevity in your answer.  0.87. What is the ratio of the Balance of Payment (as % of service imports) in Malaysia in 2005 to that in 2007?
Offer a very short reply. 0.87. What is the ratio of the Balance of Payment (as % of service imports) of Bangladesh in 2005 to that in 2008?
Provide a succinct answer. 1.15. What is the ratio of the Balance of Payment (as % of service imports) in Croatia in 2005 to that in 2008?
Keep it short and to the point. 0.97. What is the ratio of the Balance of Payment (as % of service imports) of Malaysia in 2005 to that in 2008?
Make the answer very short. 0.76. What is the ratio of the Balance of Payment (as % of service imports) of Bangladesh in 2005 to that in 2009?
Keep it short and to the point. 0.8. What is the ratio of the Balance of Payment (as % of service imports) in Croatia in 2005 to that in 2009?
Make the answer very short. 0.92. What is the ratio of the Balance of Payment (as % of service imports) of Malaysia in 2005 to that in 2009?
Offer a very short reply. 0.71. What is the ratio of the Balance of Payment (as % of service imports) in Bangladesh in 2005 to that in 2010?
Offer a very short reply. 1.09. What is the ratio of the Balance of Payment (as % of service imports) of Croatia in 2005 to that in 2010?
Ensure brevity in your answer.  1.04. What is the ratio of the Balance of Payment (as % of service imports) of Malaysia in 2005 to that in 2010?
Ensure brevity in your answer.  0.66. What is the ratio of the Balance of Payment (as % of service imports) in Bangladesh in 2005 to that in 2011?
Keep it short and to the point. 0.97. What is the ratio of the Balance of Payment (as % of service imports) in Croatia in 2005 to that in 2011?
Keep it short and to the point. 0.99. What is the ratio of the Balance of Payment (as % of service imports) in Malaysia in 2005 to that in 2011?
Ensure brevity in your answer.  0.63. What is the ratio of the Balance of Payment (as % of service imports) of Bangladesh in 2005 to that in 2012?
Offer a very short reply. 1.12. What is the ratio of the Balance of Payment (as % of service imports) of Croatia in 2005 to that in 2012?
Give a very brief answer. 0.92. What is the ratio of the Balance of Payment (as % of service imports) of Malaysia in 2005 to that in 2012?
Make the answer very short. 0.62. What is the ratio of the Balance of Payment (as % of service imports) in Bangladesh in 2006 to that in 2007?
Your answer should be very brief. 1.1. What is the ratio of the Balance of Payment (as % of service imports) of Croatia in 2006 to that in 2007?
Your answer should be very brief. 0.82. What is the ratio of the Balance of Payment (as % of service imports) of Malaysia in 2006 to that in 2007?
Ensure brevity in your answer.  0.92. What is the ratio of the Balance of Payment (as % of service imports) in Bangladesh in 2006 to that in 2008?
Ensure brevity in your answer.  1.05. What is the ratio of the Balance of Payment (as % of service imports) of Croatia in 2006 to that in 2008?
Your answer should be compact. 0.91. What is the ratio of the Balance of Payment (as % of service imports) in Malaysia in 2006 to that in 2008?
Your answer should be compact. 0.81. What is the ratio of the Balance of Payment (as % of service imports) of Bangladesh in 2006 to that in 2009?
Provide a short and direct response. 0.73. What is the ratio of the Balance of Payment (as % of service imports) of Croatia in 2006 to that in 2009?
Your answer should be compact. 0.87. What is the ratio of the Balance of Payment (as % of service imports) in Malaysia in 2006 to that in 2009?
Ensure brevity in your answer.  0.76. What is the ratio of the Balance of Payment (as % of service imports) of Bangladesh in 2006 to that in 2010?
Ensure brevity in your answer.  0.99. What is the ratio of the Balance of Payment (as % of service imports) of Croatia in 2006 to that in 2010?
Make the answer very short. 0.97. What is the ratio of the Balance of Payment (as % of service imports) of Malaysia in 2006 to that in 2010?
Make the answer very short. 0.7. What is the ratio of the Balance of Payment (as % of service imports) of Bangladesh in 2006 to that in 2011?
Offer a very short reply. 0.88. What is the ratio of the Balance of Payment (as % of service imports) in Croatia in 2006 to that in 2011?
Provide a succinct answer. 0.93. What is the ratio of the Balance of Payment (as % of service imports) of Malaysia in 2006 to that in 2011?
Provide a short and direct response. 0.68. What is the ratio of the Balance of Payment (as % of service imports) of Bangladesh in 2006 to that in 2012?
Make the answer very short. 1.02. What is the ratio of the Balance of Payment (as % of service imports) in Croatia in 2006 to that in 2012?
Ensure brevity in your answer.  0.86. What is the ratio of the Balance of Payment (as % of service imports) in Malaysia in 2006 to that in 2012?
Provide a short and direct response. 0.66. What is the ratio of the Balance of Payment (as % of service imports) of Bangladesh in 2007 to that in 2008?
Make the answer very short. 0.95. What is the ratio of the Balance of Payment (as % of service imports) of Croatia in 2007 to that in 2008?
Your answer should be compact. 1.11. What is the ratio of the Balance of Payment (as % of service imports) of Malaysia in 2007 to that in 2008?
Keep it short and to the point. 0.88. What is the ratio of the Balance of Payment (as % of service imports) in Bangladesh in 2007 to that in 2009?
Give a very brief answer. 0.66. What is the ratio of the Balance of Payment (as % of service imports) in Croatia in 2007 to that in 2009?
Provide a succinct answer. 1.06. What is the ratio of the Balance of Payment (as % of service imports) in Malaysia in 2007 to that in 2009?
Offer a terse response. 0.82. What is the ratio of the Balance of Payment (as % of service imports) of Bangladesh in 2007 to that in 2010?
Offer a terse response. 0.9. What is the ratio of the Balance of Payment (as % of service imports) of Croatia in 2007 to that in 2010?
Make the answer very short. 1.19. What is the ratio of the Balance of Payment (as % of service imports) of Malaysia in 2007 to that in 2010?
Keep it short and to the point. 0.76. What is the ratio of the Balance of Payment (as % of service imports) of Bangladesh in 2007 to that in 2011?
Offer a very short reply. 0.8. What is the ratio of the Balance of Payment (as % of service imports) in Croatia in 2007 to that in 2011?
Provide a succinct answer. 1.13. What is the ratio of the Balance of Payment (as % of service imports) in Malaysia in 2007 to that in 2011?
Your answer should be very brief. 0.73. What is the ratio of the Balance of Payment (as % of service imports) in Bangladesh in 2007 to that in 2012?
Your response must be concise. 0.93. What is the ratio of the Balance of Payment (as % of service imports) in Croatia in 2007 to that in 2012?
Offer a very short reply. 1.05. What is the ratio of the Balance of Payment (as % of service imports) of Malaysia in 2007 to that in 2012?
Give a very brief answer. 0.72. What is the ratio of the Balance of Payment (as % of service imports) of Bangladesh in 2008 to that in 2009?
Your response must be concise. 0.7. What is the ratio of the Balance of Payment (as % of service imports) of Croatia in 2008 to that in 2009?
Keep it short and to the point. 0.95. What is the ratio of the Balance of Payment (as % of service imports) in Malaysia in 2008 to that in 2009?
Your answer should be very brief. 0.94. What is the ratio of the Balance of Payment (as % of service imports) of Bangladesh in 2008 to that in 2010?
Provide a succinct answer. 0.95. What is the ratio of the Balance of Payment (as % of service imports) of Croatia in 2008 to that in 2010?
Your answer should be very brief. 1.07. What is the ratio of the Balance of Payment (as % of service imports) of Malaysia in 2008 to that in 2010?
Make the answer very short. 0.86. What is the ratio of the Balance of Payment (as % of service imports) in Bangladesh in 2008 to that in 2011?
Provide a succinct answer. 0.84. What is the ratio of the Balance of Payment (as % of service imports) of Croatia in 2008 to that in 2011?
Make the answer very short. 1.02. What is the ratio of the Balance of Payment (as % of service imports) of Malaysia in 2008 to that in 2011?
Your answer should be very brief. 0.83. What is the ratio of the Balance of Payment (as % of service imports) in Bangladesh in 2008 to that in 2012?
Ensure brevity in your answer.  0.97. What is the ratio of the Balance of Payment (as % of service imports) in Croatia in 2008 to that in 2012?
Provide a short and direct response. 0.95. What is the ratio of the Balance of Payment (as % of service imports) of Malaysia in 2008 to that in 2012?
Your answer should be compact. 0.81. What is the ratio of the Balance of Payment (as % of service imports) of Bangladesh in 2009 to that in 2010?
Provide a succinct answer. 1.36. What is the ratio of the Balance of Payment (as % of service imports) in Croatia in 2009 to that in 2010?
Keep it short and to the point. 1.12. What is the ratio of the Balance of Payment (as % of service imports) of Malaysia in 2009 to that in 2010?
Ensure brevity in your answer.  0.92. What is the ratio of the Balance of Payment (as % of service imports) of Bangladesh in 2009 to that in 2011?
Your answer should be very brief. 1.21. What is the ratio of the Balance of Payment (as % of service imports) of Croatia in 2009 to that in 2011?
Ensure brevity in your answer.  1.07. What is the ratio of the Balance of Payment (as % of service imports) in Malaysia in 2009 to that in 2011?
Provide a short and direct response. 0.89. What is the ratio of the Balance of Payment (as % of service imports) in Bangladesh in 2009 to that in 2012?
Your answer should be very brief. 1.4. What is the ratio of the Balance of Payment (as % of service imports) of Malaysia in 2009 to that in 2012?
Ensure brevity in your answer.  0.87. What is the ratio of the Balance of Payment (as % of service imports) in Bangladesh in 2010 to that in 2011?
Your response must be concise. 0.89. What is the ratio of the Balance of Payment (as % of service imports) in Croatia in 2010 to that in 2011?
Your answer should be very brief. 0.95. What is the ratio of the Balance of Payment (as % of service imports) in Malaysia in 2010 to that in 2011?
Your answer should be very brief. 0.96. What is the ratio of the Balance of Payment (as % of service imports) in Bangladesh in 2010 to that in 2012?
Offer a very short reply. 1.03. What is the ratio of the Balance of Payment (as % of service imports) in Croatia in 2010 to that in 2012?
Offer a terse response. 0.89. What is the ratio of the Balance of Payment (as % of service imports) in Malaysia in 2010 to that in 2012?
Offer a very short reply. 0.94. What is the ratio of the Balance of Payment (as % of service imports) in Bangladesh in 2011 to that in 2012?
Ensure brevity in your answer.  1.15. What is the ratio of the Balance of Payment (as % of service imports) of Croatia in 2011 to that in 2012?
Keep it short and to the point. 0.93. What is the ratio of the Balance of Payment (as % of service imports) in Malaysia in 2011 to that in 2012?
Your answer should be compact. 0.98. What is the difference between the highest and the second highest Balance of Payment (as % of service imports) of Bangladesh?
Provide a short and direct response. 1.34. What is the difference between the highest and the second highest Balance of Payment (as % of service imports) of Croatia?
Keep it short and to the point. 1.26. What is the difference between the highest and the second highest Balance of Payment (as % of service imports) of Malaysia?
Provide a short and direct response. 0.55. What is the difference between the highest and the lowest Balance of Payment (as % of service imports) in Bangladesh?
Ensure brevity in your answer.  2.57. What is the difference between the highest and the lowest Balance of Payment (as % of service imports) in Croatia?
Keep it short and to the point. 4.62. What is the difference between the highest and the lowest Balance of Payment (as % of service imports) in Malaysia?
Give a very brief answer. 10.31. 